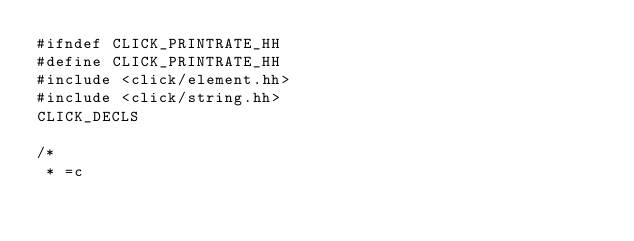<code> <loc_0><loc_0><loc_500><loc_500><_C++_>#ifndef CLICK_PRINTRATE_HH
#define CLICK_PRINTRATE_HH
#include <click/element.hh>
#include <click/string.hh>
CLICK_DECLS

/*
 * =c</code> 